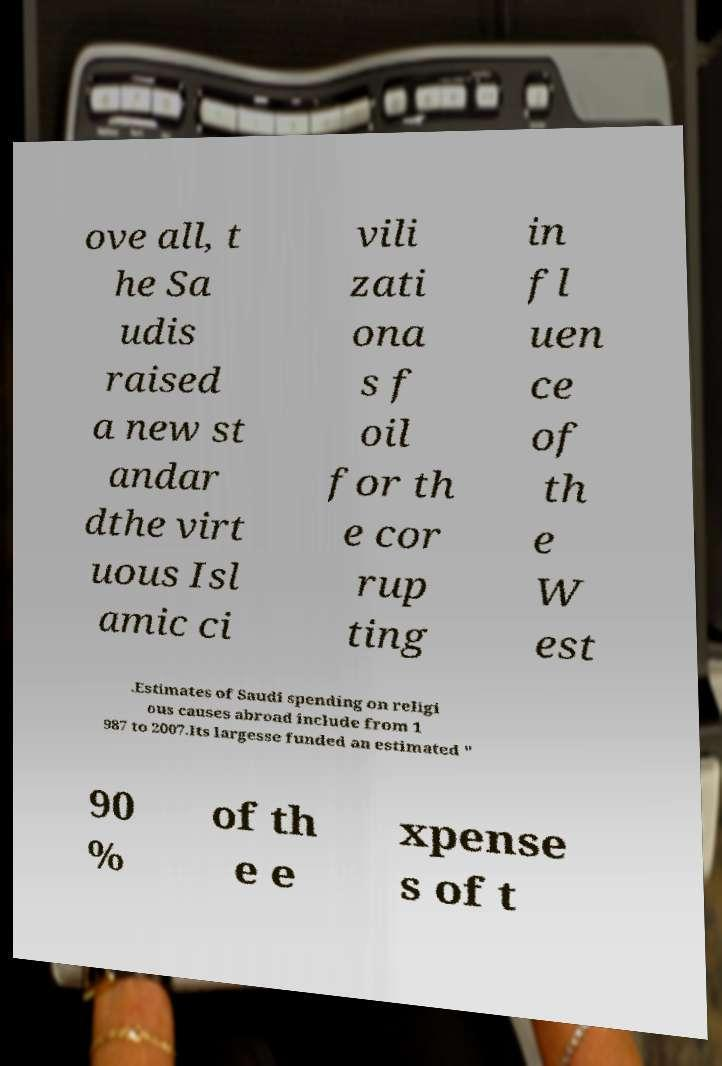Please read and relay the text visible in this image. What does it say? ove all, t he Sa udis raised a new st andar dthe virt uous Isl amic ci vili zati ona s f oil for th e cor rup ting in fl uen ce of th e W est .Estimates of Saudi spending on religi ous causes abroad include from 1 987 to 2007.Its largesse funded an estimated " 90 % of th e e xpense s of t 